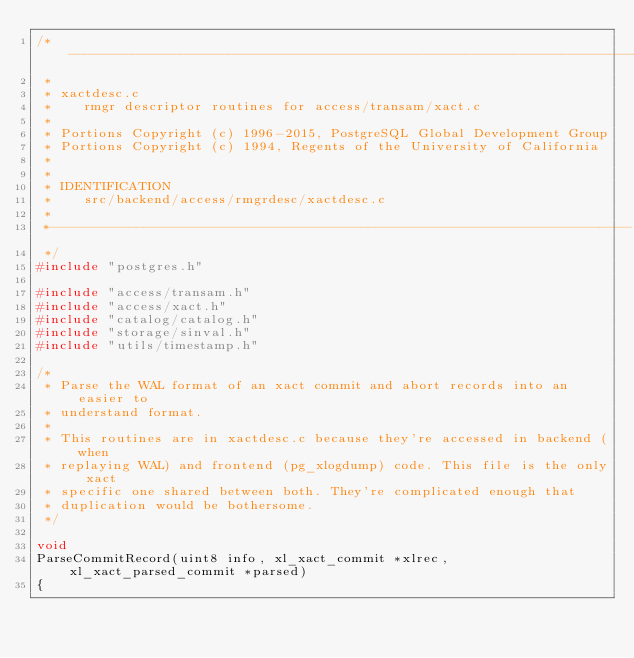Convert code to text. <code><loc_0><loc_0><loc_500><loc_500><_C++_>/*-------------------------------------------------------------------------
 *
 * xactdesc.c
 *	  rmgr descriptor routines for access/transam/xact.c
 *
 * Portions Copyright (c) 1996-2015, PostgreSQL Global Development Group
 * Portions Copyright (c) 1994, Regents of the University of California
 *
 *
 * IDENTIFICATION
 *	  src/backend/access/rmgrdesc/xactdesc.c
 *
 *-------------------------------------------------------------------------
 */
#include "postgres.h"

#include "access/transam.h"
#include "access/xact.h"
#include "catalog/catalog.h"
#include "storage/sinval.h"
#include "utils/timestamp.h"

/*
 * Parse the WAL format of an xact commit and abort records into an easier to
 * understand format.
 *
 * This routines are in xactdesc.c because they're accessed in backend (when
 * replaying WAL) and frontend (pg_xlogdump) code. This file is the only xact
 * specific one shared between both. They're complicated enough that
 * duplication would be bothersome.
 */

void
ParseCommitRecord(uint8 info, xl_xact_commit *xlrec, xl_xact_parsed_commit *parsed)
{</code> 